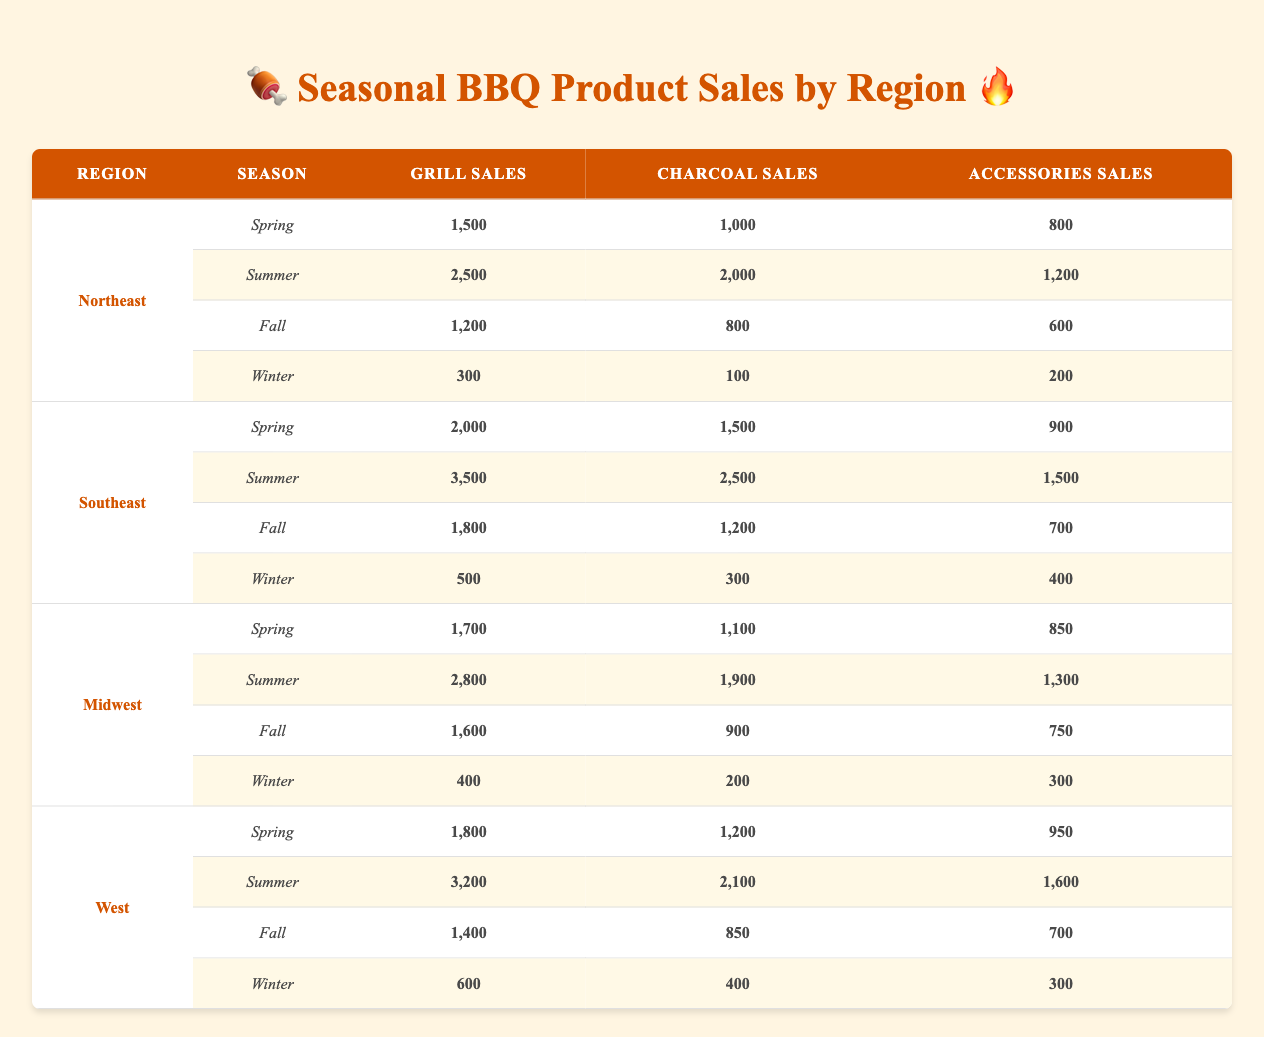What region had the highest grill sales in summer? Looking at the summer sales for all regions, the Northeast has grill sales of 2,500, the Southeast has 3,500, the Midwest has 2,800, and the West has 3,200. Comparing these values, the Southeast with 3,500 has the highest grill sales in summer.
Answer: Southeast What was the total sales of accessories in the Northeast? To find the total sales of accessories in the Northeast, we sum the accessories sales across all seasons: 800 (Spring) + 1,200 (Summer) + 600 (Fall) + 200 (Winter) = 2,800.
Answer: 2800 Is the total grill sales in winter higher in the Midwest than in the West? The total grill sales in winter for the Midwest is 400, while for the West it is 600. Since 600 is greater than 400, the total grill sales in winter is higher in the West than in the Midwest.
Answer: No Which region had the lowest total charcoal sales in spring? For spring, the charcoal sales are as follows: Northeast 1,000, Southeast 1,500, Midwest 1,100, and West 1,200. Comparing these, the Northeast has the lowest charcoal sales in spring at 1,000.
Answer: Northeast What is the average number of grill sales across all regions in the fall? The grill sales in the fall for each region are: Northeast 1,200, Southeast 1,800, Midwest 1,600, and West 1,400. The sum of these values is 1,200 + 1,800 + 1,600 + 1,400 = 6,000. To find the average, we divide this by the number of regions, which is 4. So, the average grill sales in fall is 6,000 / 4 = 1,500.
Answer: 1500 